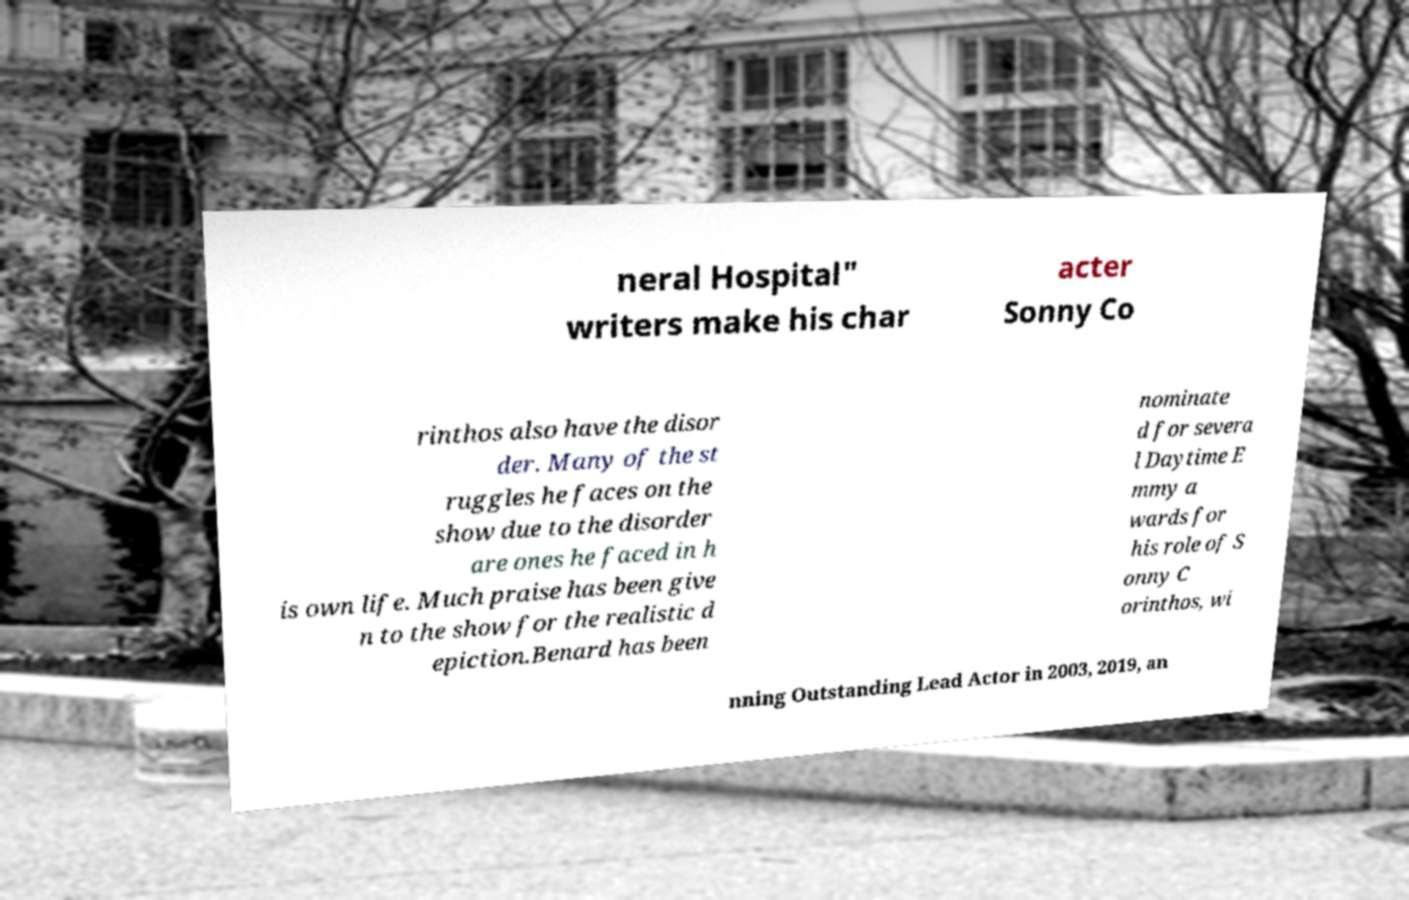What messages or text are displayed in this image? I need them in a readable, typed format. neral Hospital" writers make his char acter Sonny Co rinthos also have the disor der. Many of the st ruggles he faces on the show due to the disorder are ones he faced in h is own life. Much praise has been give n to the show for the realistic d epiction.Benard has been nominate d for severa l Daytime E mmy a wards for his role of S onny C orinthos, wi nning Outstanding Lead Actor in 2003, 2019, an 